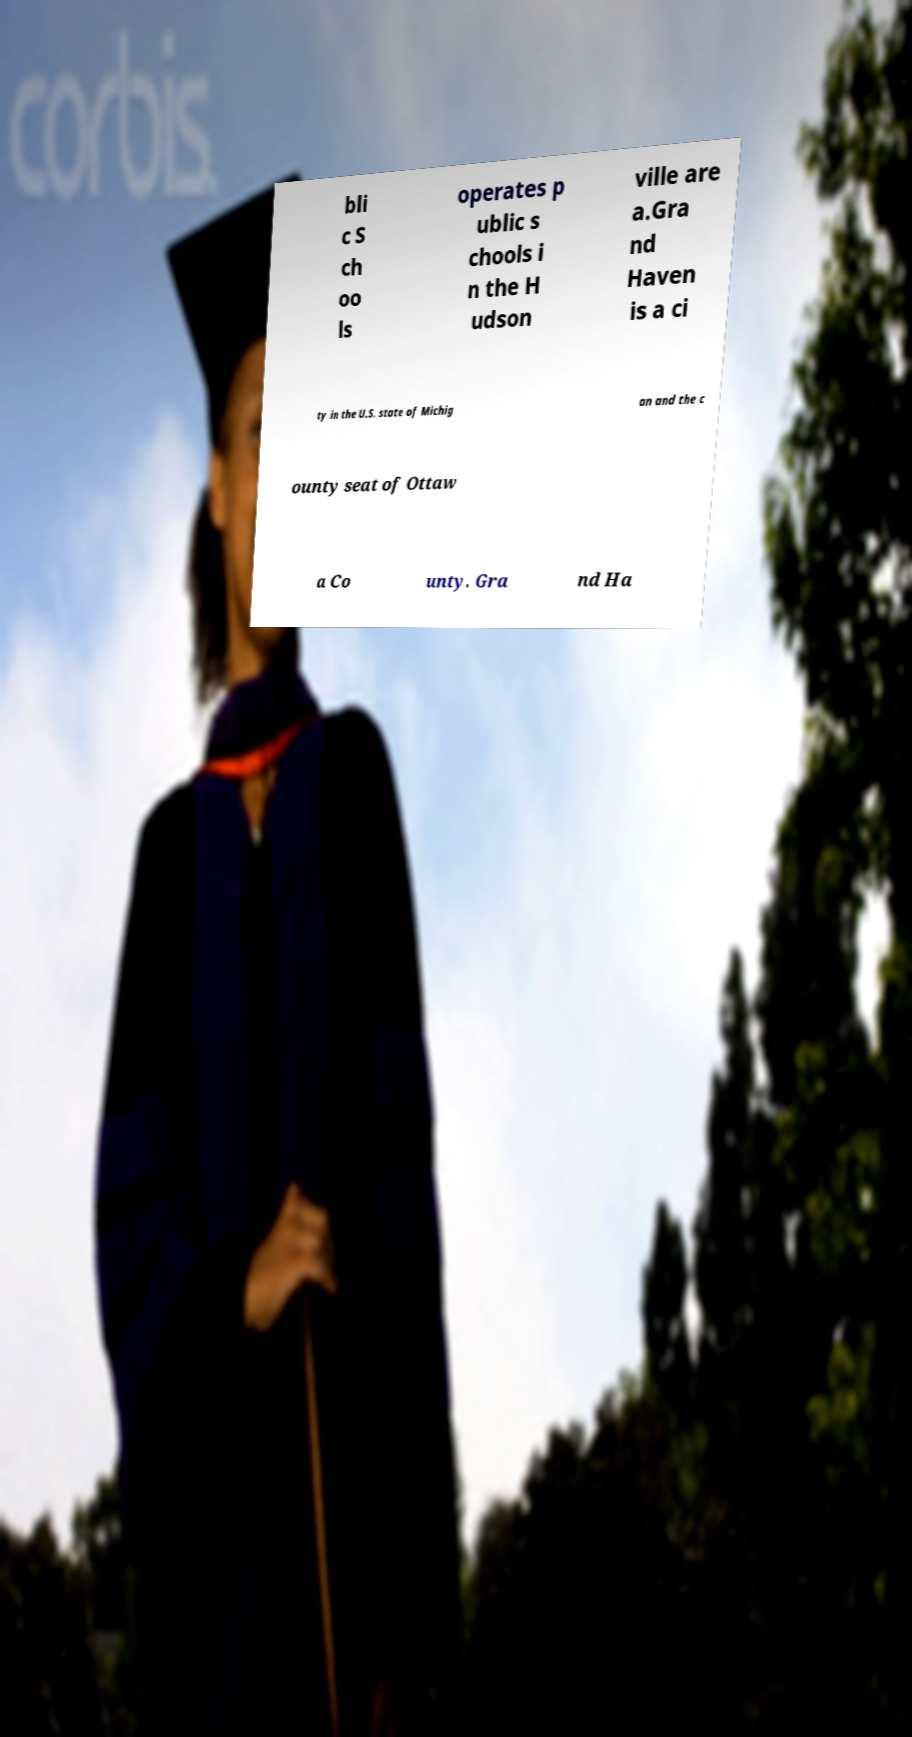Can you read and provide the text displayed in the image?This photo seems to have some interesting text. Can you extract and type it out for me? bli c S ch oo ls operates p ublic s chools i n the H udson ville are a.Gra nd Haven is a ci ty in the U.S. state of Michig an and the c ounty seat of Ottaw a Co unty. Gra nd Ha 